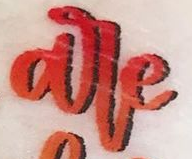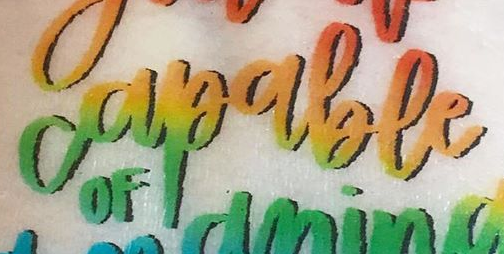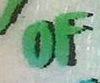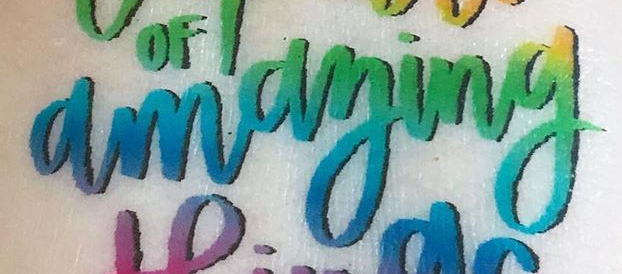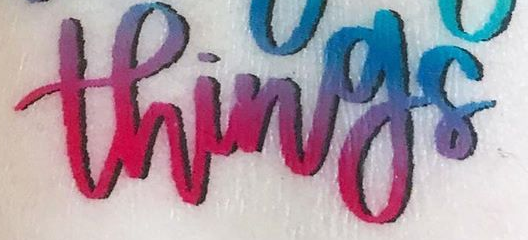What text is displayed in these images sequentially, separated by a semicolon? are; capable; OF; amaying; things 